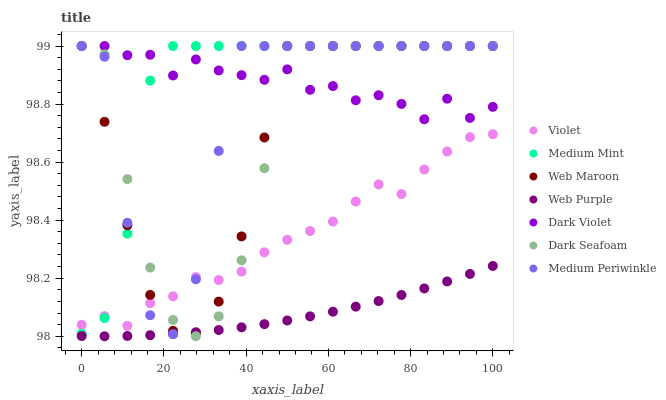Does Web Purple have the minimum area under the curve?
Answer yes or no. Yes. Does Medium Mint have the maximum area under the curve?
Answer yes or no. Yes. Does Medium Periwinkle have the minimum area under the curve?
Answer yes or no. No. Does Medium Periwinkle have the maximum area under the curve?
Answer yes or no. No. Is Web Purple the smoothest?
Answer yes or no. Yes. Is Medium Periwinkle the roughest?
Answer yes or no. Yes. Is Web Maroon the smoothest?
Answer yes or no. No. Is Web Maroon the roughest?
Answer yes or no. No. Does Web Purple have the lowest value?
Answer yes or no. Yes. Does Medium Periwinkle have the lowest value?
Answer yes or no. No. Does Dark Violet have the highest value?
Answer yes or no. Yes. Does Web Purple have the highest value?
Answer yes or no. No. Is Web Purple less than Dark Violet?
Answer yes or no. Yes. Is Dark Violet greater than Violet?
Answer yes or no. Yes. Does Dark Seafoam intersect Medium Mint?
Answer yes or no. Yes. Is Dark Seafoam less than Medium Mint?
Answer yes or no. No. Is Dark Seafoam greater than Medium Mint?
Answer yes or no. No. Does Web Purple intersect Dark Violet?
Answer yes or no. No. 